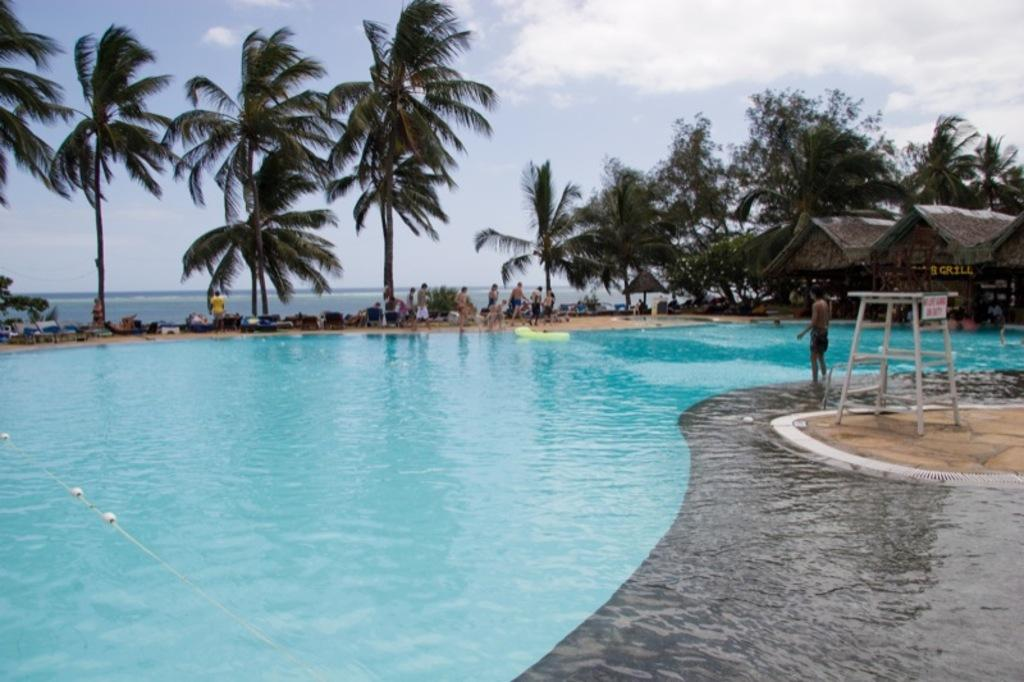How many people are in the image? There are many people in the image. What is the setting of the image? It is a swimming pool. What can be seen in the background of the image? There are trees in the image. What is the weather like in the image? The weather is hot. What is the main feature of the swimming pool? There is water in the swimming pool. What is the condition of the sky in the image? The sky is cloudy. What type of harmony can be heard in the image? There is no audible harmony in the image, as it is a visual representation of a swimming pool with many people. Can you see any icicles in the image? There are no icicles present in the image, as the weather is described as hot. 